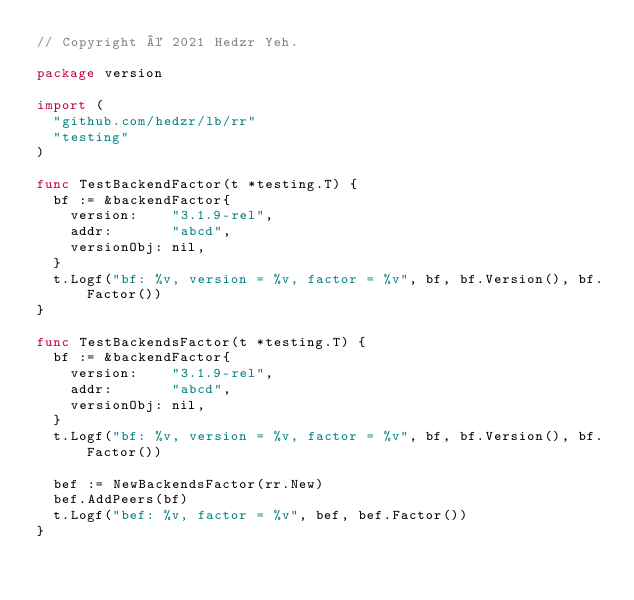<code> <loc_0><loc_0><loc_500><loc_500><_Go_>// Copyright © 2021 Hedzr Yeh.

package version

import (
	"github.com/hedzr/lb/rr"
	"testing"
)

func TestBackendFactor(t *testing.T) {
	bf := &backendFactor{
		version:    "3.1.9-rel",
		addr:       "abcd",
		versionObj: nil,
	}
	t.Logf("bf: %v, version = %v, factor = %v", bf, bf.Version(), bf.Factor())
}

func TestBackendsFactor(t *testing.T) {
	bf := &backendFactor{
		version:    "3.1.9-rel",
		addr:       "abcd",
		versionObj: nil,
	}
	t.Logf("bf: %v, version = %v, factor = %v", bf, bf.Version(), bf.Factor())

	bef := NewBackendsFactor(rr.New)
	bef.AddPeers(bf)
	t.Logf("bef: %v, factor = %v", bef, bef.Factor())
}
</code> 